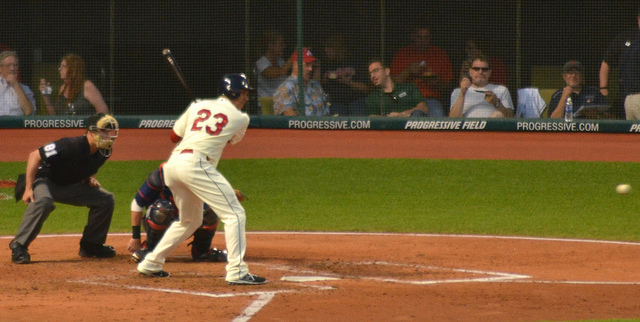Identify and read out the text in this image. PROGRESSIVE PROGRESSIVE.COM PROGRESSIVE PROGRESSIVE.COM 23 81 